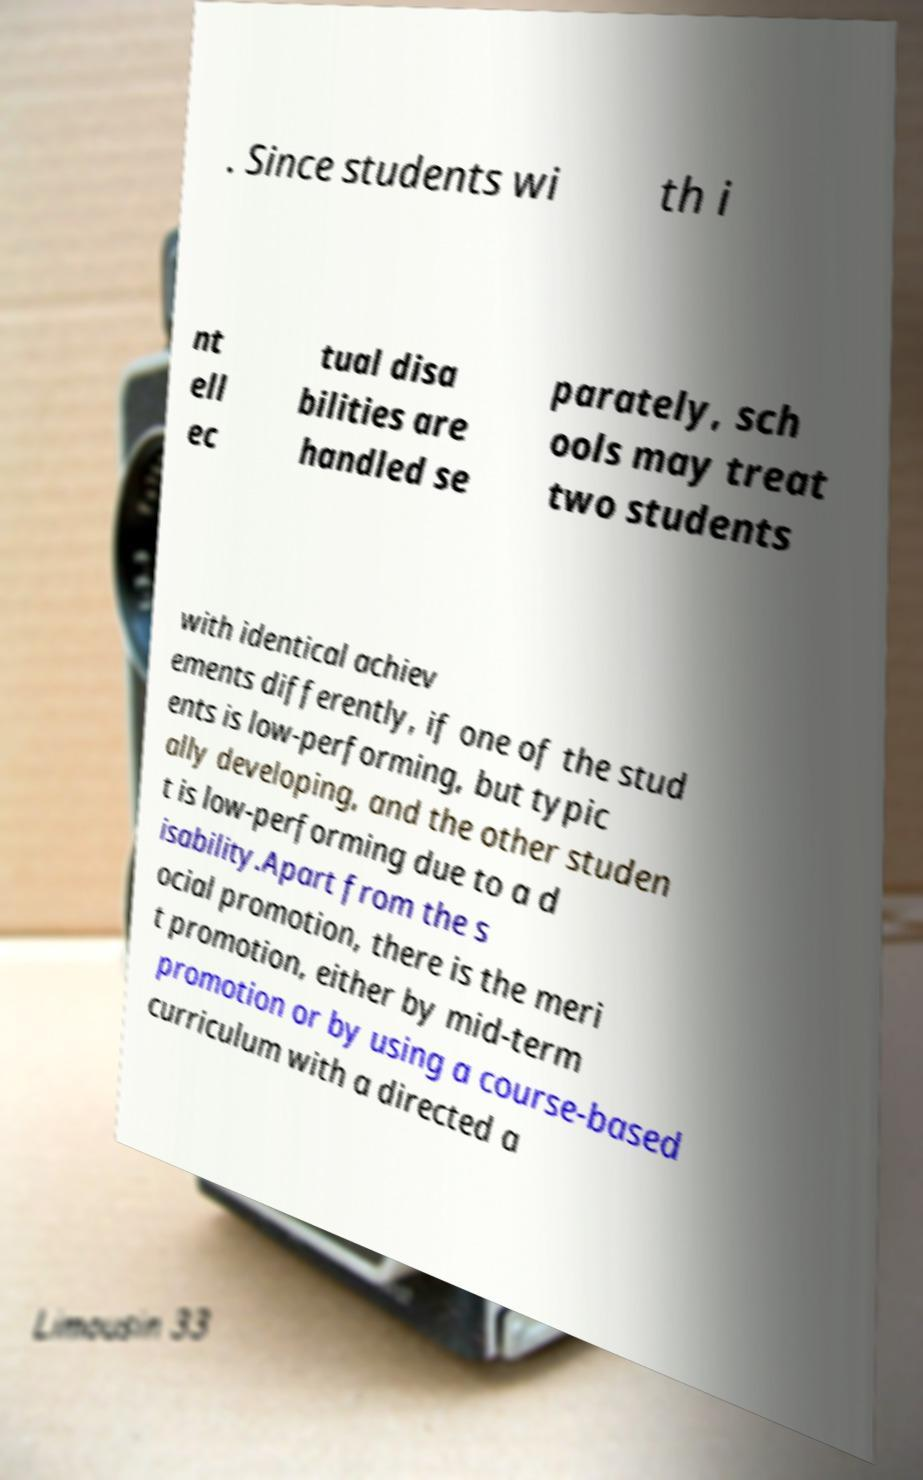Please identify and transcribe the text found in this image. . Since students wi th i nt ell ec tual disa bilities are handled se parately, sch ools may treat two students with identical achiev ements differently, if one of the stud ents is low-performing, but typic ally developing, and the other studen t is low-performing due to a d isability.Apart from the s ocial promotion, there is the meri t promotion, either by mid-term promotion or by using a course-based curriculum with a directed a 